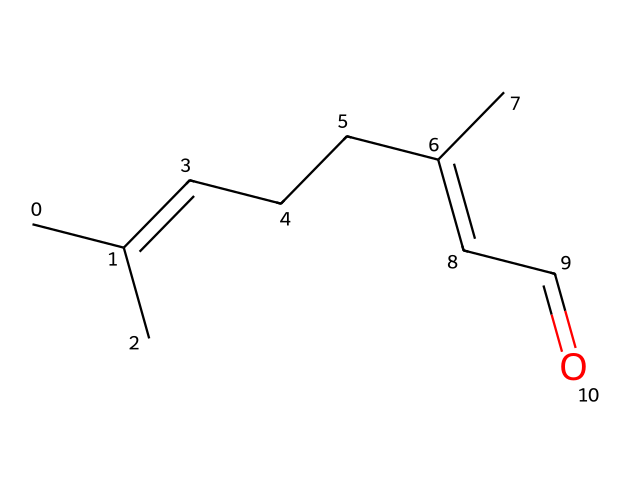What is the molecular formula of this chemical? By analyzing the given SMILES representation, I can derive the molecular formula. The structure contains 10 carbon atoms, 16 hydrogen atoms, and one oxygen atom. Consequently, the molecular formula is C10H16O.
Answer: C10H16O How many double bonds are present in this chemical? Examining the SMILES representation, I see that two double bonds are indicated in the structure, specifically in the carbon chain. Therefore, the count of double bonds is two.
Answer: two What is the functional group present in this chemical? The structure displays a carbonyl group (C=O) at the end of the carbon chain, indicative of an aldehyde functional group. Thus, the functional group in this molecule is an aldehyde.
Answer: aldehyde Is this chemical saturated or unsaturated? The presence of double bonds in the carbon chain suggests that this chemical does not have the maximum number of hydrogen atoms, meaning it is unsaturated. Therefore, the chemical is classified as unsaturated.
Answer: unsaturated What role does this chemical typically play in insect repellents? Given its structure and properties, this chemical is known for its repellent characteristics, making it effective against insects. Hence, it typically acts as an insect repellent in formulations.
Answer: insect repellent How does the presence of the carbonyl group influence the chemical's properties? The carbonyl group is polar, which enhances the molecule's solubility in polar solvents and can affect its interaction with biological membranes. This polar characteristic contributes to its effectiveness as an insect repellent.
Answer: enhances solubility 